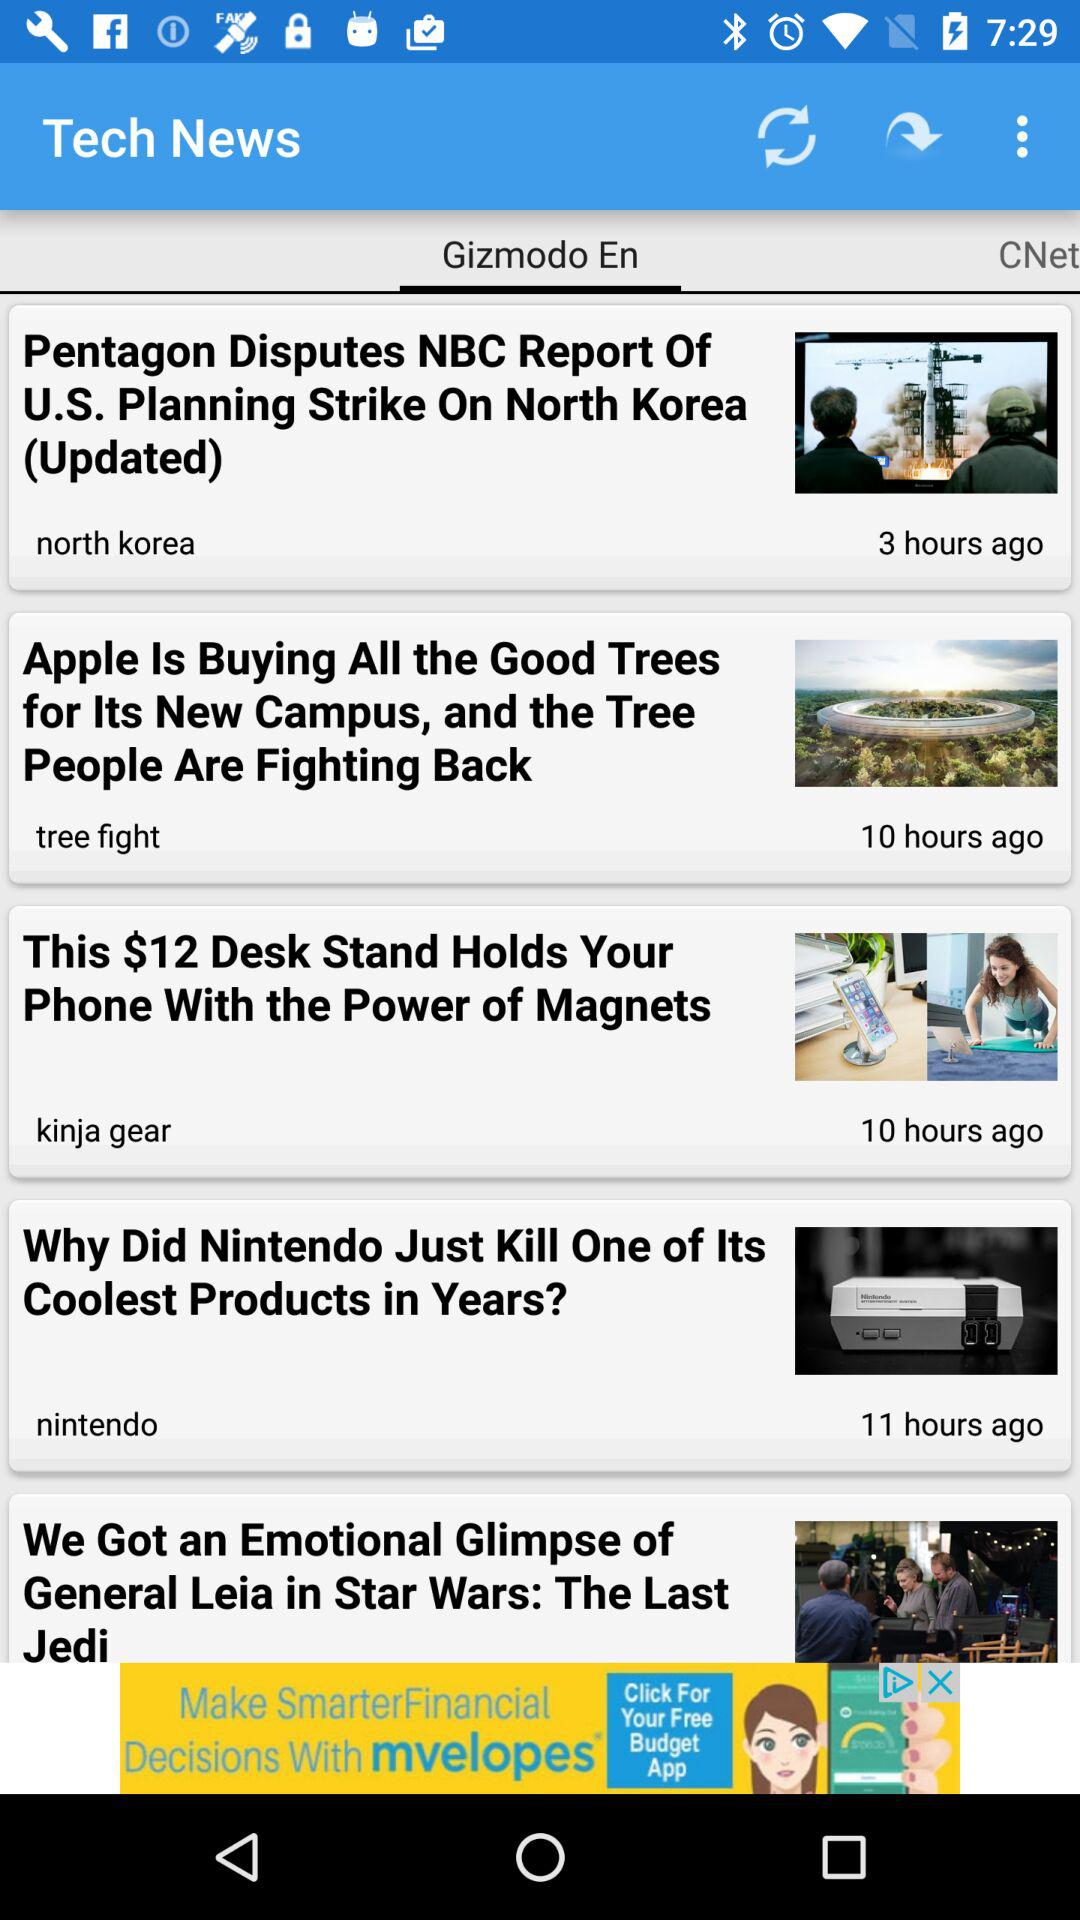What is the selected tab for tech news? The selected tab is "Gizmodo En". 